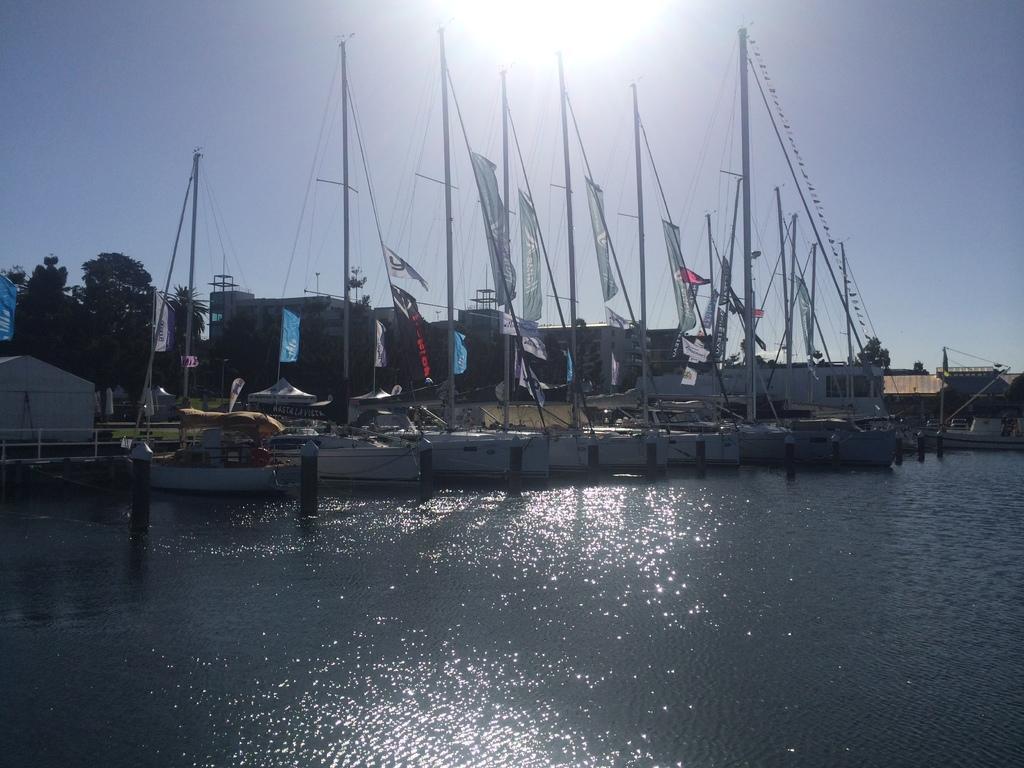How would you summarize this image in a sentence or two? This image is taken outdoors. At the bottom of the image there is the sky with the sun. At the bottom of the image there is a river with water. In the background there are a few trees and there are a few houses. In the middle of the image there are many boats on the river. There are many poles and flags. 